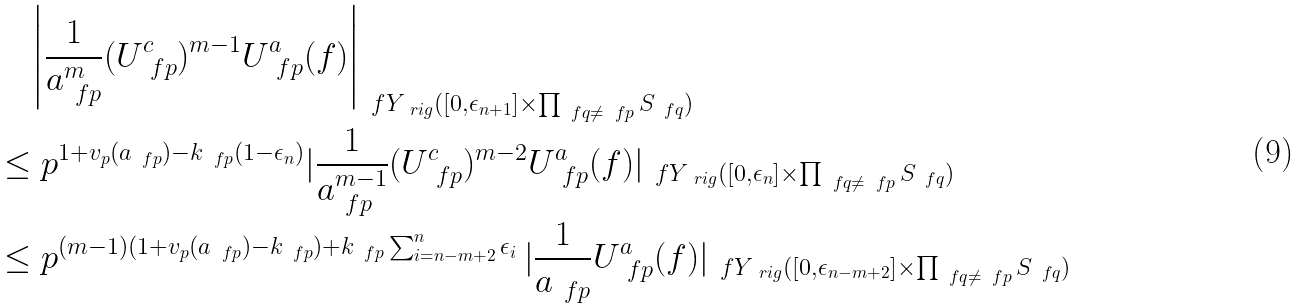<formula> <loc_0><loc_0><loc_500><loc_500>& \quad \left | \frac { 1 } { a _ { \ f p } ^ { m } } ( U _ { \ f p } ^ { c } ) ^ { m - 1 } U _ { \ f p } ^ { a } ( f ) \right | _ { \ f Y _ { \ r i g } ( [ 0 , \epsilon _ { n + 1 } ] \times \prod _ { \ f q \neq \ f p } S _ { \ f q } ) } \\ & \leq p ^ { 1 + v _ { p } ( a _ { \ f p } ) - k _ { \ f p } ( 1 - \epsilon _ { n } ) } | \frac { 1 } { a _ { \ f p } ^ { m - 1 } } ( U _ { \ f p } ^ { c } ) ^ { m - 2 } U _ { \ f p } ^ { a } ( f ) | _ { \ f Y _ { \ r i g } ( [ 0 , \epsilon _ { n } ] \times \prod _ { \ f q \neq \ f p } S _ { \ f q } ) } \\ & \leq p ^ { ( m - 1 ) ( 1 + v _ { p } ( a _ { \ f p } ) - k _ { \ f p } ) + k _ { \ f p } \sum _ { i = n - m + 2 } ^ { n } \epsilon _ { i } } \, | \frac { 1 } { a _ { \ f p } } U _ { \ f p } ^ { a } ( f ) | _ { \ f Y _ { \ r i g } ( [ 0 , \epsilon _ { n - m + 2 } ] \times \prod _ { \ f q \neq \ f p } S _ { \ f q } ) }</formula> 